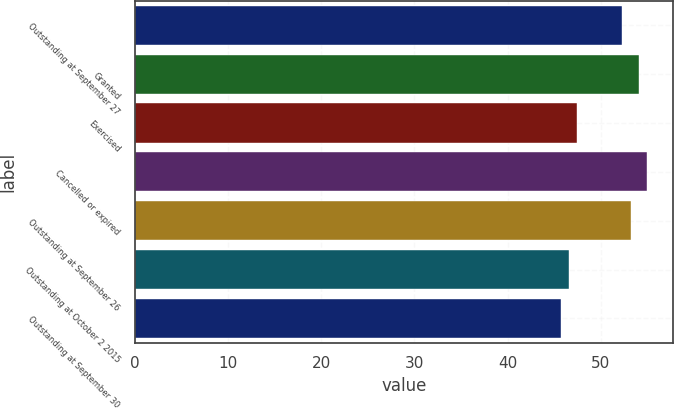Convert chart to OTSL. <chart><loc_0><loc_0><loc_500><loc_500><bar_chart><fcel>Outstanding at September 27<fcel>Granted<fcel>Exercised<fcel>Cancelled or expired<fcel>Outstanding at September 26<fcel>Outstanding at October 2 2015<fcel>Outstanding at September 30<nl><fcel>52.33<fcel>54.11<fcel>47.45<fcel>54.99<fcel>53.23<fcel>46.57<fcel>45.69<nl></chart> 